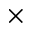<formula> <loc_0><loc_0><loc_500><loc_500>\times</formula> 